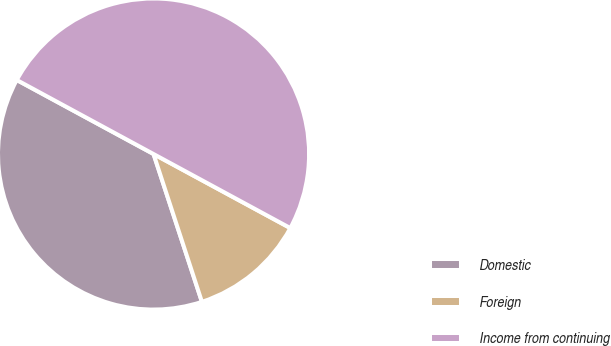Convert chart. <chart><loc_0><loc_0><loc_500><loc_500><pie_chart><fcel>Domestic<fcel>Foreign<fcel>Income from continuing<nl><fcel>37.93%<fcel>12.07%<fcel>50.0%<nl></chart> 